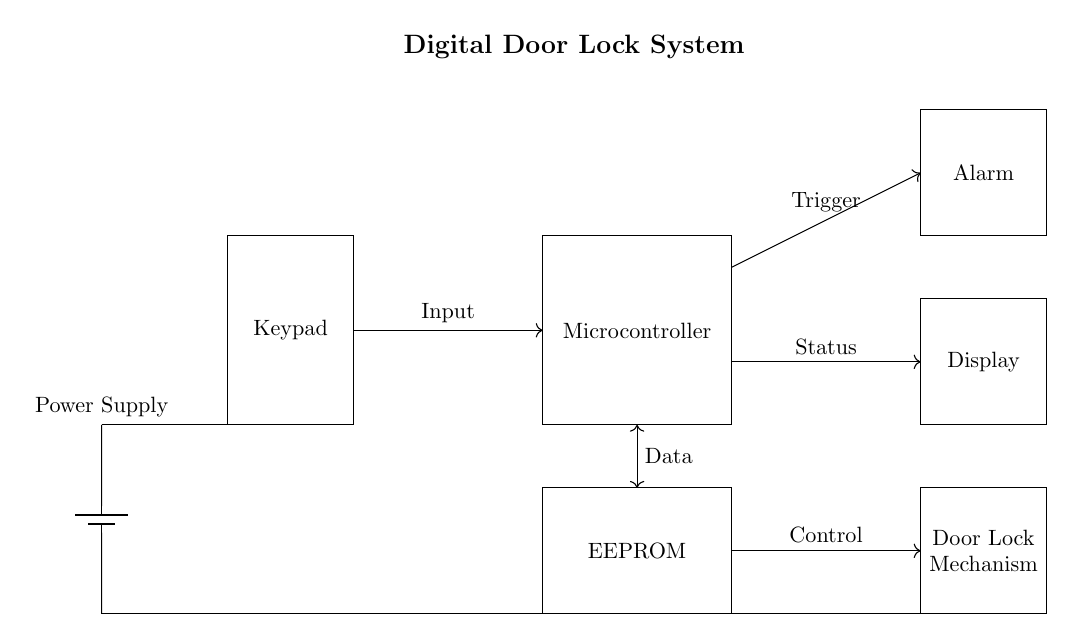What are the main components in the circuit? The circuit includes a keypad, microcontroller, display, door lock mechanism, EEPROM, alarm, and power supply. These components are the primary parts needed for the digital door lock system to function properly.
Answer: Keypad, microcontroller, display, door lock mechanism, EEPROM, alarm, power supply What triggers the alarm? The microcontroller sends a trigger signal to the alarm component when a specific condition is met, such as an incorrect entry or unauthorized access attempt. This relationship is indicated by the arrow connecting the microcontroller to the alarm.
Answer: Microcontroller Where is the power supply connected? The power supply is connected to both the keypad and the EEPROM, providing the necessary voltage and current for their operation, as indicated by the lines connecting them.
Answer: Keypad and EEPROM What is the role of the EEPROM in this circuit? The EEPROM stores data related to access codes and system configurations that the microcontroller can retrieve and modify. The connection lines show a bidirectional relationship, indicating that data can flow between the microcontroller and the EEPROM.
Answer: Store access codes How does the input flow from the keypad to the microcontroller? The input signal is directed from the keypad to the microcontroller through a line labeled as "Input," indicating that the keypad delivers data to the microcontroller for processing.
Answer: Through an input line What type of control does the microcontroller exert over the door lock mechanism? The microcontroller exerts control over the door lock mechanism via a control signal, as indicated by the connection labeled "Control," which signifies that the microcontroller can send commands to lock or unlock the door based on input validation.
Answer: Control signal 